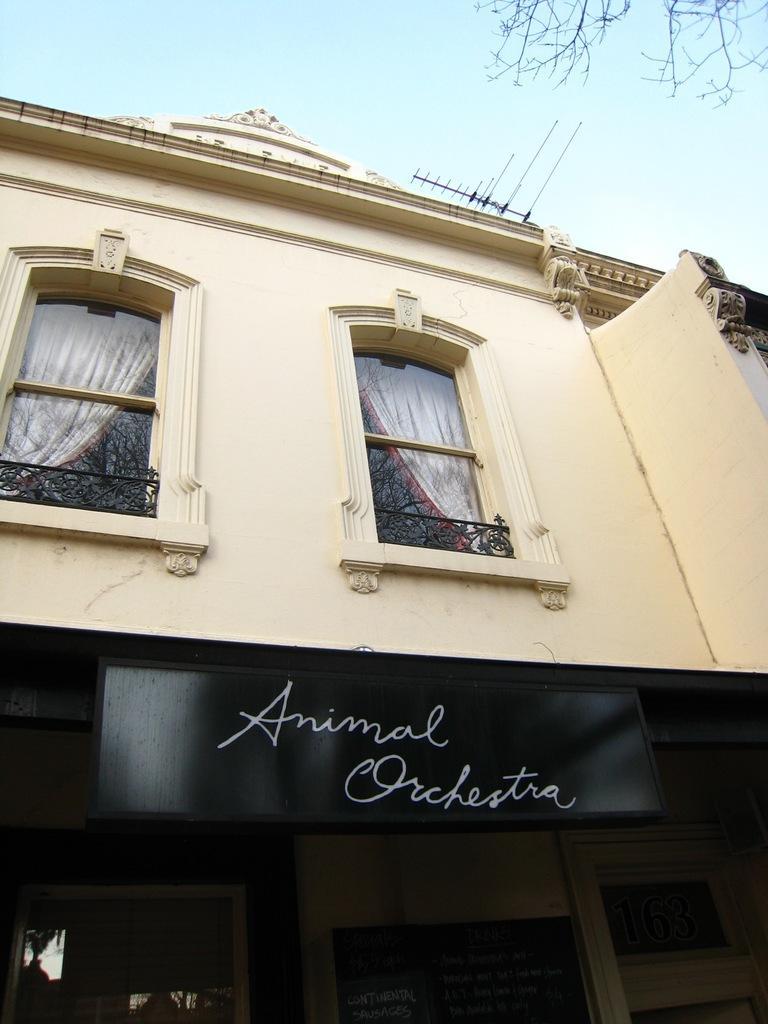In one or two sentences, can you explain what this image depicts? In this picture I can observe a building in the middle of the picture. In the background there is sky. 